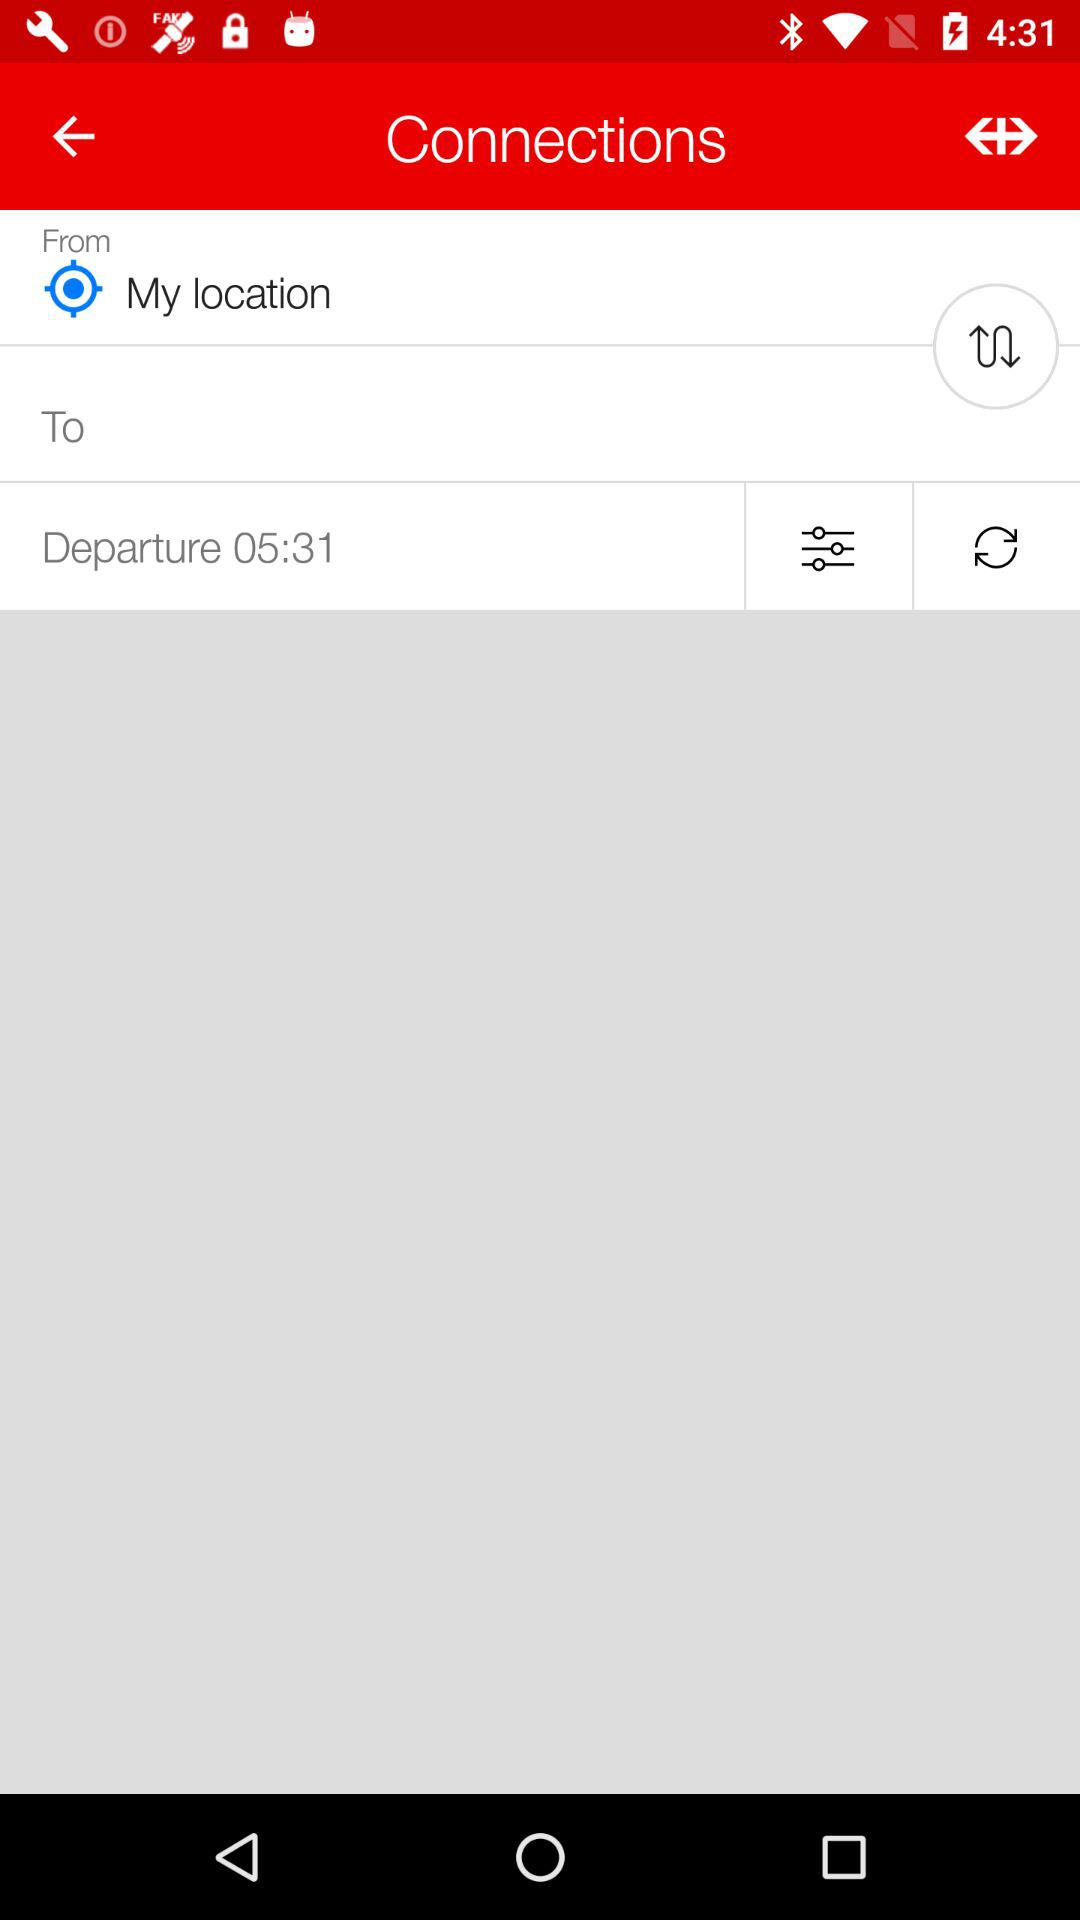What is the departure time? The departure time is 05:31. 